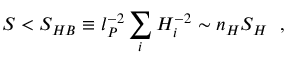Convert formula to latex. <formula><loc_0><loc_0><loc_500><loc_500>S < S _ { H B } \equiv l _ { P } ^ { - 2 } \sum _ { i } H _ { i } ^ { - 2 } \sim n _ { H } S _ { H } ,</formula> 